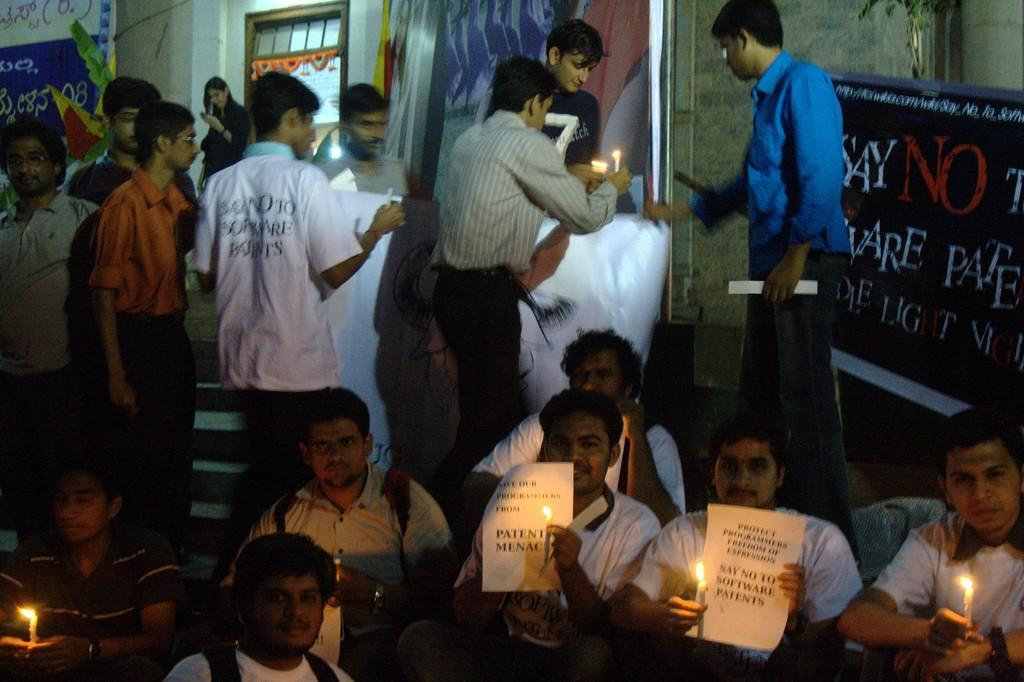What are the people in the image doing? The people in the image are sitting on the floor and holding candles in their hands. Can you describe the people in the background of the image? The people in the background are also standing and holding candles in their hands. What is visible in the image besides the people? There is a wall visible in the image. What type of paste is being used to stick the candles to the wall in the image? There is no paste or candles attached to the wall in the image; the people are holding the candles. 